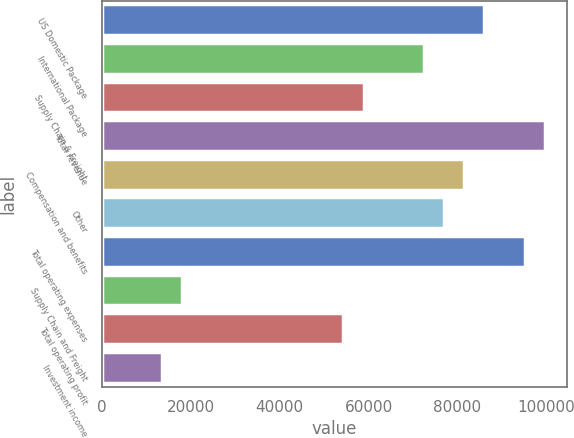Convert chart. <chart><loc_0><loc_0><loc_500><loc_500><bar_chart><fcel>US Domestic Package<fcel>International Package<fcel>Supply Chain & Freight<fcel>Total revenue<fcel>Compensation and benefits<fcel>Other<fcel>Total operating expenses<fcel>Supply Chain and Freight<fcel>Total operating profit<fcel>Investment income<nl><fcel>86062.7<fcel>72474.1<fcel>58885.6<fcel>99651.2<fcel>81533.2<fcel>77003.6<fcel>95121.7<fcel>18119.9<fcel>54356<fcel>13590.4<nl></chart> 